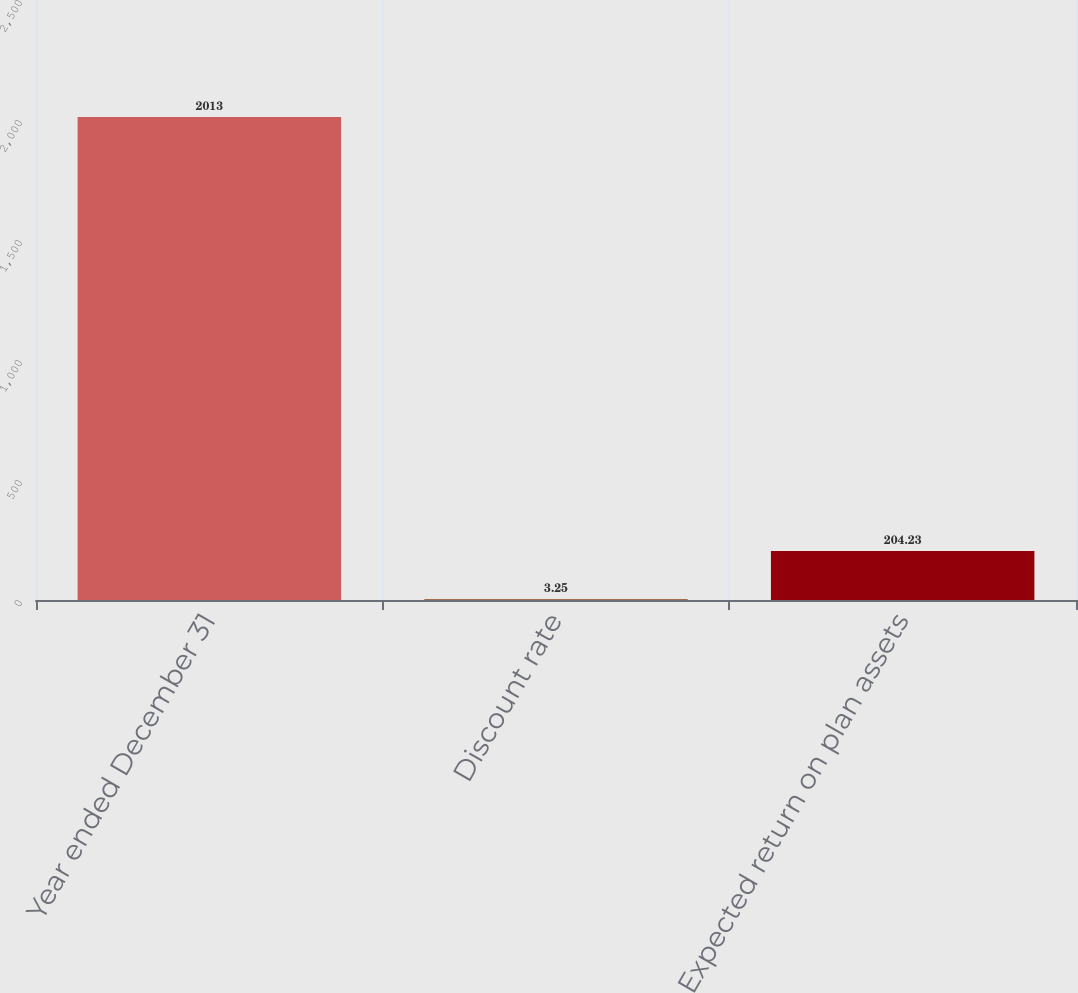<chart> <loc_0><loc_0><loc_500><loc_500><bar_chart><fcel>Year ended December 31<fcel>Discount rate<fcel>Expected return on plan assets<nl><fcel>2013<fcel>3.25<fcel>204.23<nl></chart> 